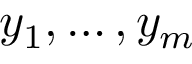<formula> <loc_0><loc_0><loc_500><loc_500>y _ { 1 } , \dots , y _ { m }</formula> 